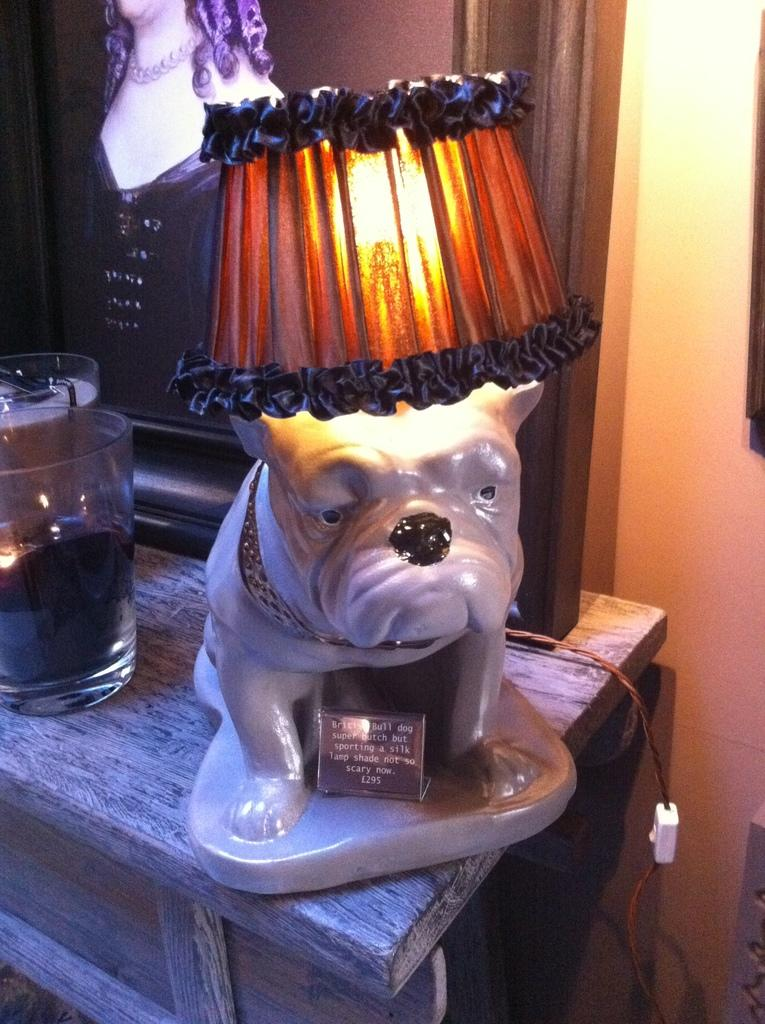What object can be seen providing light in the image? There is a lamp in the image. What items are on the table in the image? There are glasses on the table. What can be seen in the background of the image? There is a photo frame and a switch in the background. What type of army is depicted in the photo frame in the image? There is no army depicted in the photo frame in the image; it contains a different subject or scene. What tool is being used by the father in the image? There is no father or tool usage depicted in the image. 